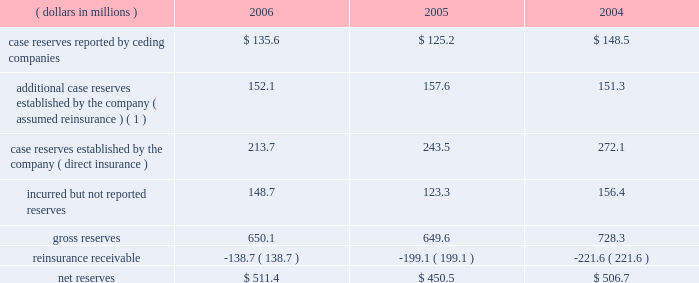Development of prior year incurred losses was $ 135.6 million unfavorable in 2006 , $ 26.4 million favorable in 2005 and $ 249.4 million unfavorable in 2004 .
Such losses were the result of the reserve development noted above , as well as inher- ent uncertainty in establishing loss and lae reserves .
Reserves for asbestos and environmental losses and loss adjustment expenses as of year end 2006 , 7.4% ( 7.4 % ) of reserves reflect an estimate for the company 2019s ultimate liability for a&e claims for which ulti- mate value cannot be estimated using traditional reserving techniques .
The company 2019s a&e liabilities stem from mt .
Mckinley 2019s direct insurance business and everest re 2019s assumed reinsurance business .
There are significant uncertainties in estimating the amount of the company 2019s potential losses from a&e claims .
See item 7 , 201cmanagement 2019s discussion and analysis of financial condition and results of operations 2014asbestos and environmental exposures 201d and note 3 of notes to consolidated financial statements .
Mt .
Mckinley 2019s book of direct a&e exposed insurance is relatively small and homogenous .
It also arises from a limited period , effective 1978 to 1984 .
The book is based principally on excess liability policies , thereby limiting exposure analysis to a lim- ited number of policies and forms .
As a result of this focused structure , the company believes that it is able to comprehen- sively analyze its exposures , allowing it to identify , analyze and actively monitor those claims which have unusual exposure , including policies in which it may be exposed to pay expenses in addition to policy limits or non-products asbestos claims .
The company endeavors to be actively engaged with every insured account posing significant potential asbestos exposure to mt .
Mckinley .
Such engagement can take the form of pursuing a final settlement , negotiation , litigation , or the monitoring of claim activity under settlement in place ( 201csip 201d ) agreements .
Sip agreements generally condition an insurer 2019s payment upon the actual claim experience of the insured and may have annual payment caps or other measures to control the insurer 2019s payments .
The company 2019s mt .
Mckinley operation is currently managing eight sip agreements , three of which were executed prior to the acquisition of mt .
Mckinley in 2000 .
The company 2019s preference with respect to coverage settlements is to exe- cute settlements that call for a fixed schedule of payments , because such settlements eliminate future uncertainty .
The company has significantly enhanced its classification of insureds by exposure characteristics over time , as well as its analysis by insured for those it considers to be more exposed or active .
Those insureds identified as relatively less exposed or active are subject to less rigorous , but still active management , with an emphasis on monitoring those characteristics , which may indicate an increasing exposure or levels of activity .
The company continually focuses on further enhancement of the detailed estimation processes used to evaluate potential exposure of policyholders , including those that may not have reported significant a&e losses .
Everest re 2019s book of assumed reinsurance is relatively concentrated within a modest number of a&e exposed relationships .
It also arises from a limited period , effectively 1977 to 1984 .
Because the book of business is relatively concentrated and the company has been managing the a&e exposures for many years , its claim staff is familiar with the ceding companies that have generated most of these liabilities in the past and which are therefore most likely to generate future liabilities .
The company 2019s claim staff has developed familiarity both with the nature of the business written by its ceding companies and the claims handling and reserving practices of those companies .
This level of familiarity enhances the quality of the company 2019s analysis of its exposure through those companies .
As a result , the company believes that it can identify those claims on which it has unusual exposure , such as non-products asbestos claims , for concentrated attention .
However , in setting reserves for its reinsurance liabilities , the company relies on claims data supplied , both formally and informally by its ceding companies and brokers .
This furnished information is not always timely or accurate and can impact the accuracy and timeli- ness of the company 2019s ultimate loss projections .
The table summarizes the composition of the company 2019s total reserves for a&e losses , gross and net of reinsurance , for the years ended december 31: .
( 1 ) additional reserves are case specific reserves determined by the company to be needed over and above those reported by the ceding company .
81790fin_a 4/13/07 11:08 am page 15 .
What was the percentage change in the net reserves from 2005 to 2006? 
Computations: ((511.4 - 450.5) / 450.5)
Answer: 0.13518. 